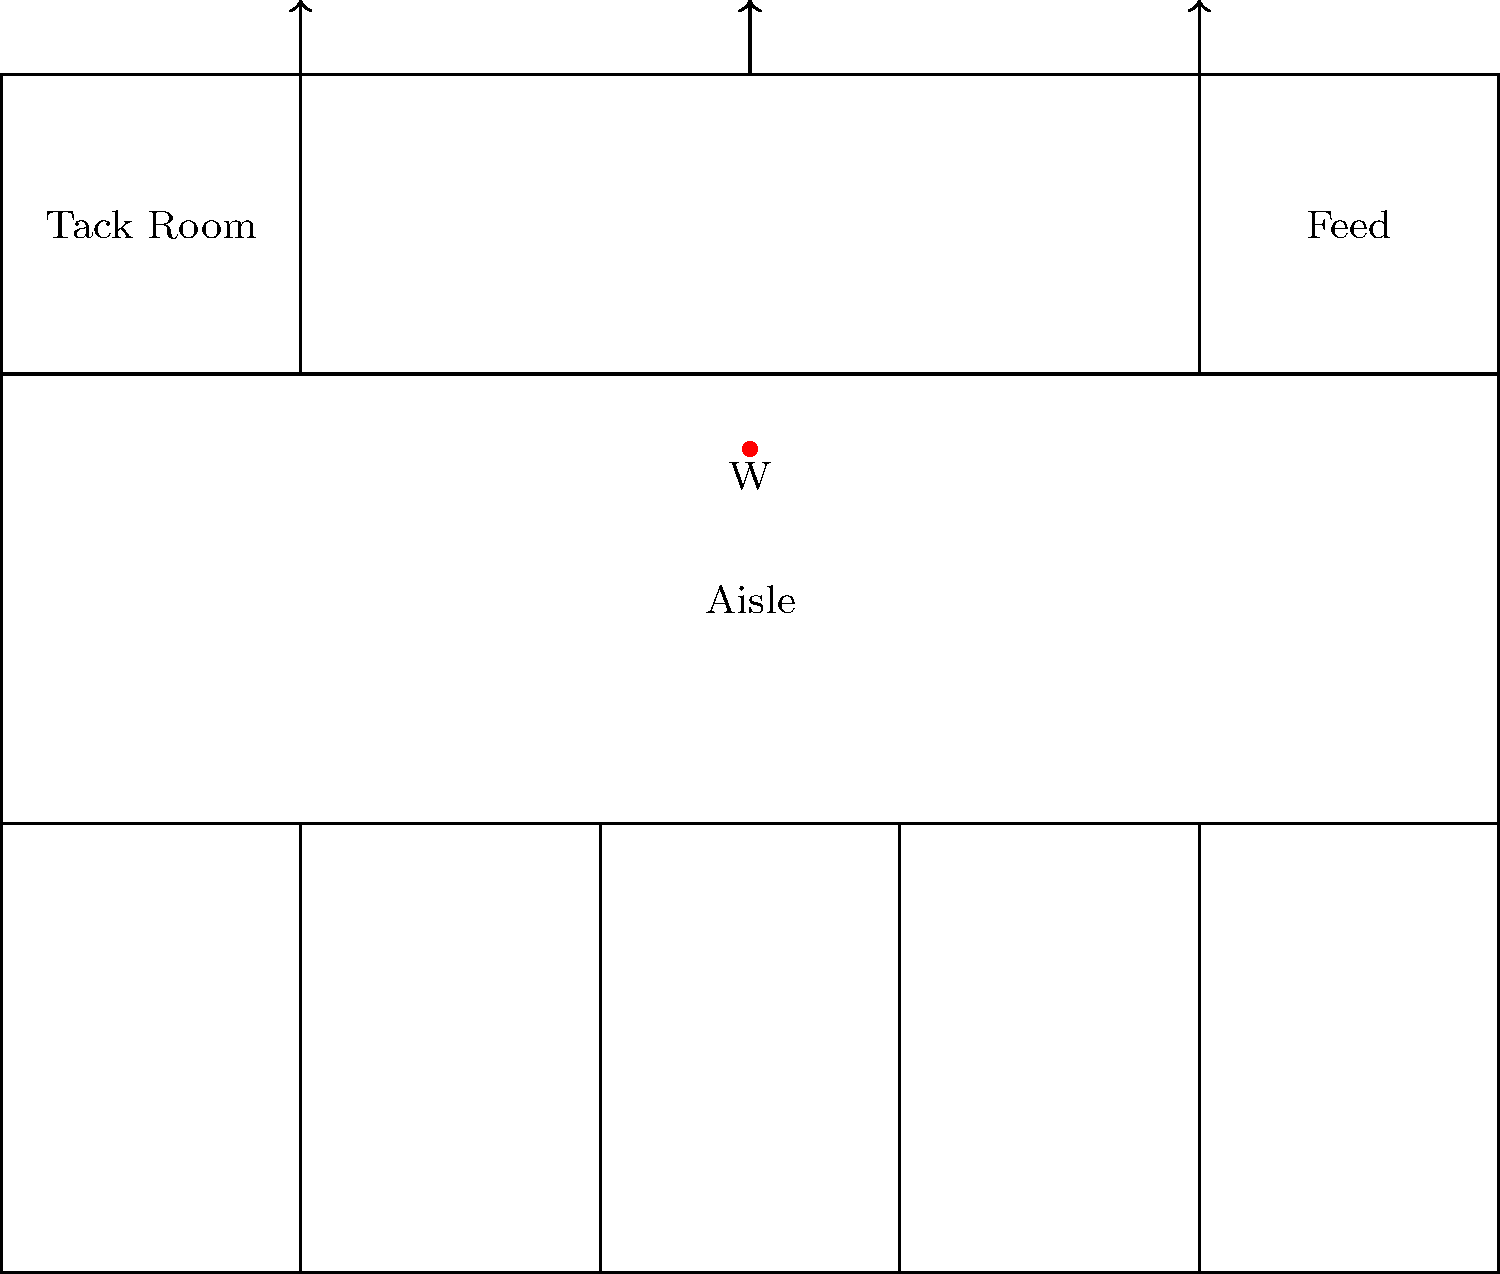In the stable layout shown above, which design element is crucial for maintaining good air quality and reducing respiratory issues in horses, and where is it represented in the diagram? To answer this question, we need to consider the key elements of stable design that affect horse health, particularly respiratory health:

1. Ventilation is crucial for maintaining good air quality in stables. Poor ventilation can lead to the accumulation of dust, ammonia, and other airborne particles that can cause respiratory issues in horses.

2. In the diagram, ventilation is represented by the three arrows at the top of the stable (at positions 2, 5, and 8 on the x-axis).

3. These arrows indicate airflow, suggesting that there are openings or vents in the roof or upper walls of the stable. This design allows for natural ventilation, where stale air can rise and exit the building while fresh air enters from lower openings.

4. Proper ventilation helps to:
   - Remove excess moisture
   - Reduce the concentration of airborne contaminants
   - Regulate temperature
   - Provide fresh air for the horses

5. The placement of these ventilation points across the length of the stable ensures that air can circulate throughout the entire building, reaching all stalls and common areas.

Therefore, the ventilation system, represented by the arrows at the top of the diagram, is the crucial design element for maintaining good air quality and reducing respiratory issues in horses.
Answer: Ventilation, represented by arrows at the top of the stable. 